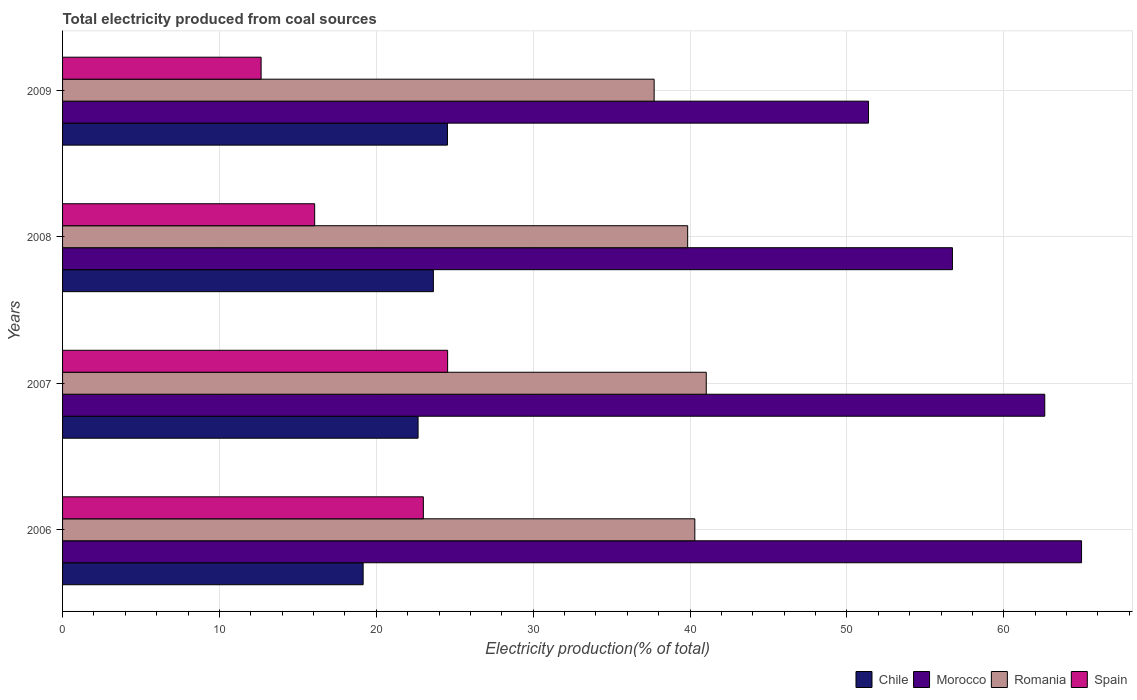How many different coloured bars are there?
Provide a short and direct response. 4. How many groups of bars are there?
Your answer should be compact. 4. Are the number of bars per tick equal to the number of legend labels?
Keep it short and to the point. Yes. Are the number of bars on each tick of the Y-axis equal?
Offer a terse response. Yes. How many bars are there on the 2nd tick from the top?
Your response must be concise. 4. How many bars are there on the 3rd tick from the bottom?
Offer a very short reply. 4. In how many cases, is the number of bars for a given year not equal to the number of legend labels?
Offer a terse response. 0. What is the total electricity produced in Romania in 2008?
Offer a very short reply. 39.85. Across all years, what is the maximum total electricity produced in Spain?
Ensure brevity in your answer.  24.54. Across all years, what is the minimum total electricity produced in Chile?
Provide a succinct answer. 19.16. In which year was the total electricity produced in Morocco maximum?
Offer a very short reply. 2006. In which year was the total electricity produced in Spain minimum?
Ensure brevity in your answer.  2009. What is the total total electricity produced in Romania in the graph?
Provide a short and direct response. 158.89. What is the difference between the total electricity produced in Chile in 2007 and that in 2008?
Provide a succinct answer. -0.98. What is the difference between the total electricity produced in Morocco in 2008 and the total electricity produced in Romania in 2007?
Offer a very short reply. 15.69. What is the average total electricity produced in Romania per year?
Offer a very short reply. 39.72. In the year 2006, what is the difference between the total electricity produced in Chile and total electricity produced in Spain?
Ensure brevity in your answer.  -3.84. In how many years, is the total electricity produced in Spain greater than 52 %?
Keep it short and to the point. 0. What is the ratio of the total electricity produced in Chile in 2008 to that in 2009?
Your response must be concise. 0.96. Is the total electricity produced in Romania in 2007 less than that in 2009?
Give a very brief answer. No. What is the difference between the highest and the second highest total electricity produced in Morocco?
Offer a terse response. 2.34. What is the difference between the highest and the lowest total electricity produced in Morocco?
Keep it short and to the point. 13.58. In how many years, is the total electricity produced in Chile greater than the average total electricity produced in Chile taken over all years?
Make the answer very short. 3. What does the 1st bar from the top in 2008 represents?
Your response must be concise. Spain. What does the 2nd bar from the bottom in 2006 represents?
Your answer should be compact. Morocco. Are all the bars in the graph horizontal?
Offer a very short reply. Yes. How many years are there in the graph?
Your response must be concise. 4. What is the difference between two consecutive major ticks on the X-axis?
Offer a terse response. 10. Are the values on the major ticks of X-axis written in scientific E-notation?
Provide a short and direct response. No. Does the graph contain any zero values?
Provide a short and direct response. No. Where does the legend appear in the graph?
Provide a succinct answer. Bottom right. How are the legend labels stacked?
Your answer should be very brief. Horizontal. What is the title of the graph?
Offer a very short reply. Total electricity produced from coal sources. What is the label or title of the X-axis?
Make the answer very short. Electricity production(% of total). What is the Electricity production(% of total) of Chile in 2006?
Your answer should be compact. 19.16. What is the Electricity production(% of total) of Morocco in 2006?
Offer a terse response. 64.95. What is the Electricity production(% of total) in Romania in 2006?
Keep it short and to the point. 40.3. What is the Electricity production(% of total) of Spain in 2006?
Offer a terse response. 23. What is the Electricity production(% of total) of Chile in 2007?
Your answer should be compact. 22.66. What is the Electricity production(% of total) in Morocco in 2007?
Provide a short and direct response. 62.61. What is the Electricity production(% of total) in Romania in 2007?
Your answer should be compact. 41.03. What is the Electricity production(% of total) of Spain in 2007?
Keep it short and to the point. 24.54. What is the Electricity production(% of total) in Chile in 2008?
Offer a very short reply. 23.64. What is the Electricity production(% of total) of Morocco in 2008?
Your answer should be very brief. 56.72. What is the Electricity production(% of total) in Romania in 2008?
Offer a very short reply. 39.85. What is the Electricity production(% of total) of Spain in 2008?
Offer a terse response. 16.07. What is the Electricity production(% of total) of Chile in 2009?
Provide a short and direct response. 24.53. What is the Electricity production(% of total) of Morocco in 2009?
Give a very brief answer. 51.37. What is the Electricity production(% of total) in Romania in 2009?
Offer a terse response. 37.71. What is the Electricity production(% of total) of Spain in 2009?
Offer a terse response. 12.66. Across all years, what is the maximum Electricity production(% of total) of Chile?
Give a very brief answer. 24.53. Across all years, what is the maximum Electricity production(% of total) in Morocco?
Your answer should be compact. 64.95. Across all years, what is the maximum Electricity production(% of total) in Romania?
Keep it short and to the point. 41.03. Across all years, what is the maximum Electricity production(% of total) of Spain?
Give a very brief answer. 24.54. Across all years, what is the minimum Electricity production(% of total) in Chile?
Your answer should be very brief. 19.16. Across all years, what is the minimum Electricity production(% of total) of Morocco?
Your response must be concise. 51.37. Across all years, what is the minimum Electricity production(% of total) of Romania?
Provide a succinct answer. 37.71. Across all years, what is the minimum Electricity production(% of total) of Spain?
Provide a short and direct response. 12.66. What is the total Electricity production(% of total) in Chile in the graph?
Keep it short and to the point. 89.99. What is the total Electricity production(% of total) of Morocco in the graph?
Ensure brevity in your answer.  235.65. What is the total Electricity production(% of total) in Romania in the graph?
Offer a very short reply. 158.89. What is the total Electricity production(% of total) in Spain in the graph?
Give a very brief answer. 76.27. What is the difference between the Electricity production(% of total) in Chile in 2006 and that in 2007?
Provide a succinct answer. -3.5. What is the difference between the Electricity production(% of total) of Morocco in 2006 and that in 2007?
Offer a very short reply. 2.34. What is the difference between the Electricity production(% of total) of Romania in 2006 and that in 2007?
Your answer should be compact. -0.73. What is the difference between the Electricity production(% of total) in Spain in 2006 and that in 2007?
Offer a very short reply. -1.55. What is the difference between the Electricity production(% of total) of Chile in 2006 and that in 2008?
Make the answer very short. -4.48. What is the difference between the Electricity production(% of total) in Morocco in 2006 and that in 2008?
Your response must be concise. 8.23. What is the difference between the Electricity production(% of total) in Romania in 2006 and that in 2008?
Make the answer very short. 0.46. What is the difference between the Electricity production(% of total) of Spain in 2006 and that in 2008?
Ensure brevity in your answer.  6.93. What is the difference between the Electricity production(% of total) in Chile in 2006 and that in 2009?
Provide a succinct answer. -5.37. What is the difference between the Electricity production(% of total) of Morocco in 2006 and that in 2009?
Your answer should be compact. 13.58. What is the difference between the Electricity production(% of total) of Romania in 2006 and that in 2009?
Your response must be concise. 2.59. What is the difference between the Electricity production(% of total) in Spain in 2006 and that in 2009?
Provide a succinct answer. 10.34. What is the difference between the Electricity production(% of total) of Chile in 2007 and that in 2008?
Provide a succinct answer. -0.98. What is the difference between the Electricity production(% of total) in Morocco in 2007 and that in 2008?
Your response must be concise. 5.89. What is the difference between the Electricity production(% of total) in Romania in 2007 and that in 2008?
Ensure brevity in your answer.  1.19. What is the difference between the Electricity production(% of total) of Spain in 2007 and that in 2008?
Offer a very short reply. 8.47. What is the difference between the Electricity production(% of total) in Chile in 2007 and that in 2009?
Ensure brevity in your answer.  -1.87. What is the difference between the Electricity production(% of total) in Morocco in 2007 and that in 2009?
Offer a very short reply. 11.23. What is the difference between the Electricity production(% of total) of Romania in 2007 and that in 2009?
Your response must be concise. 3.32. What is the difference between the Electricity production(% of total) of Spain in 2007 and that in 2009?
Provide a short and direct response. 11.89. What is the difference between the Electricity production(% of total) in Chile in 2008 and that in 2009?
Offer a terse response. -0.9. What is the difference between the Electricity production(% of total) of Morocco in 2008 and that in 2009?
Provide a succinct answer. 5.35. What is the difference between the Electricity production(% of total) in Romania in 2008 and that in 2009?
Offer a terse response. 2.14. What is the difference between the Electricity production(% of total) of Spain in 2008 and that in 2009?
Your answer should be compact. 3.41. What is the difference between the Electricity production(% of total) of Chile in 2006 and the Electricity production(% of total) of Morocco in 2007?
Your answer should be compact. -43.45. What is the difference between the Electricity production(% of total) in Chile in 2006 and the Electricity production(% of total) in Romania in 2007?
Offer a terse response. -21.87. What is the difference between the Electricity production(% of total) of Chile in 2006 and the Electricity production(% of total) of Spain in 2007?
Give a very brief answer. -5.39. What is the difference between the Electricity production(% of total) in Morocco in 2006 and the Electricity production(% of total) in Romania in 2007?
Make the answer very short. 23.92. What is the difference between the Electricity production(% of total) in Morocco in 2006 and the Electricity production(% of total) in Spain in 2007?
Offer a terse response. 40.41. What is the difference between the Electricity production(% of total) of Romania in 2006 and the Electricity production(% of total) of Spain in 2007?
Offer a very short reply. 15.76. What is the difference between the Electricity production(% of total) in Chile in 2006 and the Electricity production(% of total) in Morocco in 2008?
Provide a succinct answer. -37.56. What is the difference between the Electricity production(% of total) of Chile in 2006 and the Electricity production(% of total) of Romania in 2008?
Your answer should be compact. -20.69. What is the difference between the Electricity production(% of total) of Chile in 2006 and the Electricity production(% of total) of Spain in 2008?
Ensure brevity in your answer.  3.09. What is the difference between the Electricity production(% of total) of Morocco in 2006 and the Electricity production(% of total) of Romania in 2008?
Offer a very short reply. 25.11. What is the difference between the Electricity production(% of total) in Morocco in 2006 and the Electricity production(% of total) in Spain in 2008?
Ensure brevity in your answer.  48.88. What is the difference between the Electricity production(% of total) of Romania in 2006 and the Electricity production(% of total) of Spain in 2008?
Provide a short and direct response. 24.23. What is the difference between the Electricity production(% of total) in Chile in 2006 and the Electricity production(% of total) in Morocco in 2009?
Your response must be concise. -32.21. What is the difference between the Electricity production(% of total) in Chile in 2006 and the Electricity production(% of total) in Romania in 2009?
Your response must be concise. -18.55. What is the difference between the Electricity production(% of total) of Chile in 2006 and the Electricity production(% of total) of Spain in 2009?
Give a very brief answer. 6.5. What is the difference between the Electricity production(% of total) of Morocco in 2006 and the Electricity production(% of total) of Romania in 2009?
Ensure brevity in your answer.  27.24. What is the difference between the Electricity production(% of total) of Morocco in 2006 and the Electricity production(% of total) of Spain in 2009?
Give a very brief answer. 52.3. What is the difference between the Electricity production(% of total) in Romania in 2006 and the Electricity production(% of total) in Spain in 2009?
Provide a short and direct response. 27.65. What is the difference between the Electricity production(% of total) of Chile in 2007 and the Electricity production(% of total) of Morocco in 2008?
Provide a succinct answer. -34.06. What is the difference between the Electricity production(% of total) of Chile in 2007 and the Electricity production(% of total) of Romania in 2008?
Your answer should be very brief. -17.18. What is the difference between the Electricity production(% of total) in Chile in 2007 and the Electricity production(% of total) in Spain in 2008?
Provide a succinct answer. 6.59. What is the difference between the Electricity production(% of total) in Morocco in 2007 and the Electricity production(% of total) in Romania in 2008?
Make the answer very short. 22.76. What is the difference between the Electricity production(% of total) of Morocco in 2007 and the Electricity production(% of total) of Spain in 2008?
Provide a short and direct response. 46.54. What is the difference between the Electricity production(% of total) in Romania in 2007 and the Electricity production(% of total) in Spain in 2008?
Your answer should be very brief. 24.96. What is the difference between the Electricity production(% of total) of Chile in 2007 and the Electricity production(% of total) of Morocco in 2009?
Provide a short and direct response. -28.71. What is the difference between the Electricity production(% of total) in Chile in 2007 and the Electricity production(% of total) in Romania in 2009?
Give a very brief answer. -15.05. What is the difference between the Electricity production(% of total) in Chile in 2007 and the Electricity production(% of total) in Spain in 2009?
Keep it short and to the point. 10.01. What is the difference between the Electricity production(% of total) in Morocco in 2007 and the Electricity production(% of total) in Romania in 2009?
Keep it short and to the point. 24.9. What is the difference between the Electricity production(% of total) in Morocco in 2007 and the Electricity production(% of total) in Spain in 2009?
Make the answer very short. 49.95. What is the difference between the Electricity production(% of total) of Romania in 2007 and the Electricity production(% of total) of Spain in 2009?
Provide a succinct answer. 28.38. What is the difference between the Electricity production(% of total) in Chile in 2008 and the Electricity production(% of total) in Morocco in 2009?
Offer a very short reply. -27.74. What is the difference between the Electricity production(% of total) of Chile in 2008 and the Electricity production(% of total) of Romania in 2009?
Your answer should be very brief. -14.07. What is the difference between the Electricity production(% of total) of Chile in 2008 and the Electricity production(% of total) of Spain in 2009?
Your response must be concise. 10.98. What is the difference between the Electricity production(% of total) of Morocco in 2008 and the Electricity production(% of total) of Romania in 2009?
Keep it short and to the point. 19.01. What is the difference between the Electricity production(% of total) in Morocco in 2008 and the Electricity production(% of total) in Spain in 2009?
Your answer should be compact. 44.07. What is the difference between the Electricity production(% of total) of Romania in 2008 and the Electricity production(% of total) of Spain in 2009?
Give a very brief answer. 27.19. What is the average Electricity production(% of total) of Chile per year?
Your answer should be compact. 22.5. What is the average Electricity production(% of total) of Morocco per year?
Keep it short and to the point. 58.91. What is the average Electricity production(% of total) of Romania per year?
Offer a terse response. 39.72. What is the average Electricity production(% of total) in Spain per year?
Make the answer very short. 19.07. In the year 2006, what is the difference between the Electricity production(% of total) in Chile and Electricity production(% of total) in Morocco?
Ensure brevity in your answer.  -45.79. In the year 2006, what is the difference between the Electricity production(% of total) in Chile and Electricity production(% of total) in Romania?
Your answer should be very brief. -21.14. In the year 2006, what is the difference between the Electricity production(% of total) in Chile and Electricity production(% of total) in Spain?
Provide a short and direct response. -3.84. In the year 2006, what is the difference between the Electricity production(% of total) of Morocco and Electricity production(% of total) of Romania?
Make the answer very short. 24.65. In the year 2006, what is the difference between the Electricity production(% of total) of Morocco and Electricity production(% of total) of Spain?
Provide a succinct answer. 41.95. In the year 2006, what is the difference between the Electricity production(% of total) in Romania and Electricity production(% of total) in Spain?
Provide a succinct answer. 17.3. In the year 2007, what is the difference between the Electricity production(% of total) of Chile and Electricity production(% of total) of Morocco?
Ensure brevity in your answer.  -39.95. In the year 2007, what is the difference between the Electricity production(% of total) of Chile and Electricity production(% of total) of Romania?
Give a very brief answer. -18.37. In the year 2007, what is the difference between the Electricity production(% of total) in Chile and Electricity production(% of total) in Spain?
Give a very brief answer. -1.88. In the year 2007, what is the difference between the Electricity production(% of total) in Morocco and Electricity production(% of total) in Romania?
Keep it short and to the point. 21.58. In the year 2007, what is the difference between the Electricity production(% of total) in Morocco and Electricity production(% of total) in Spain?
Your answer should be compact. 38.06. In the year 2007, what is the difference between the Electricity production(% of total) in Romania and Electricity production(% of total) in Spain?
Keep it short and to the point. 16.49. In the year 2008, what is the difference between the Electricity production(% of total) in Chile and Electricity production(% of total) in Morocco?
Your answer should be very brief. -33.09. In the year 2008, what is the difference between the Electricity production(% of total) in Chile and Electricity production(% of total) in Romania?
Offer a terse response. -16.21. In the year 2008, what is the difference between the Electricity production(% of total) in Chile and Electricity production(% of total) in Spain?
Offer a terse response. 7.57. In the year 2008, what is the difference between the Electricity production(% of total) of Morocco and Electricity production(% of total) of Romania?
Offer a very short reply. 16.88. In the year 2008, what is the difference between the Electricity production(% of total) of Morocco and Electricity production(% of total) of Spain?
Keep it short and to the point. 40.65. In the year 2008, what is the difference between the Electricity production(% of total) in Romania and Electricity production(% of total) in Spain?
Your response must be concise. 23.78. In the year 2009, what is the difference between the Electricity production(% of total) in Chile and Electricity production(% of total) in Morocco?
Give a very brief answer. -26.84. In the year 2009, what is the difference between the Electricity production(% of total) of Chile and Electricity production(% of total) of Romania?
Give a very brief answer. -13.17. In the year 2009, what is the difference between the Electricity production(% of total) of Chile and Electricity production(% of total) of Spain?
Your answer should be very brief. 11.88. In the year 2009, what is the difference between the Electricity production(% of total) in Morocco and Electricity production(% of total) in Romania?
Provide a short and direct response. 13.67. In the year 2009, what is the difference between the Electricity production(% of total) in Morocco and Electricity production(% of total) in Spain?
Provide a short and direct response. 38.72. In the year 2009, what is the difference between the Electricity production(% of total) of Romania and Electricity production(% of total) of Spain?
Your response must be concise. 25.05. What is the ratio of the Electricity production(% of total) of Chile in 2006 to that in 2007?
Ensure brevity in your answer.  0.85. What is the ratio of the Electricity production(% of total) of Morocco in 2006 to that in 2007?
Your answer should be compact. 1.04. What is the ratio of the Electricity production(% of total) in Romania in 2006 to that in 2007?
Provide a succinct answer. 0.98. What is the ratio of the Electricity production(% of total) of Spain in 2006 to that in 2007?
Provide a succinct answer. 0.94. What is the ratio of the Electricity production(% of total) of Chile in 2006 to that in 2008?
Your answer should be very brief. 0.81. What is the ratio of the Electricity production(% of total) of Morocco in 2006 to that in 2008?
Offer a very short reply. 1.15. What is the ratio of the Electricity production(% of total) in Romania in 2006 to that in 2008?
Your answer should be compact. 1.01. What is the ratio of the Electricity production(% of total) in Spain in 2006 to that in 2008?
Provide a short and direct response. 1.43. What is the ratio of the Electricity production(% of total) of Chile in 2006 to that in 2009?
Offer a terse response. 0.78. What is the ratio of the Electricity production(% of total) in Morocco in 2006 to that in 2009?
Your answer should be compact. 1.26. What is the ratio of the Electricity production(% of total) of Romania in 2006 to that in 2009?
Provide a succinct answer. 1.07. What is the ratio of the Electricity production(% of total) of Spain in 2006 to that in 2009?
Your response must be concise. 1.82. What is the ratio of the Electricity production(% of total) of Chile in 2007 to that in 2008?
Make the answer very short. 0.96. What is the ratio of the Electricity production(% of total) of Morocco in 2007 to that in 2008?
Give a very brief answer. 1.1. What is the ratio of the Electricity production(% of total) in Romania in 2007 to that in 2008?
Offer a very short reply. 1.03. What is the ratio of the Electricity production(% of total) in Spain in 2007 to that in 2008?
Your answer should be compact. 1.53. What is the ratio of the Electricity production(% of total) in Chile in 2007 to that in 2009?
Offer a terse response. 0.92. What is the ratio of the Electricity production(% of total) of Morocco in 2007 to that in 2009?
Your response must be concise. 1.22. What is the ratio of the Electricity production(% of total) of Romania in 2007 to that in 2009?
Give a very brief answer. 1.09. What is the ratio of the Electricity production(% of total) of Spain in 2007 to that in 2009?
Your response must be concise. 1.94. What is the ratio of the Electricity production(% of total) in Chile in 2008 to that in 2009?
Your answer should be compact. 0.96. What is the ratio of the Electricity production(% of total) in Morocco in 2008 to that in 2009?
Provide a short and direct response. 1.1. What is the ratio of the Electricity production(% of total) of Romania in 2008 to that in 2009?
Offer a very short reply. 1.06. What is the ratio of the Electricity production(% of total) in Spain in 2008 to that in 2009?
Your answer should be compact. 1.27. What is the difference between the highest and the second highest Electricity production(% of total) in Chile?
Your answer should be very brief. 0.9. What is the difference between the highest and the second highest Electricity production(% of total) of Morocco?
Provide a short and direct response. 2.34. What is the difference between the highest and the second highest Electricity production(% of total) in Romania?
Your answer should be compact. 0.73. What is the difference between the highest and the second highest Electricity production(% of total) in Spain?
Give a very brief answer. 1.55. What is the difference between the highest and the lowest Electricity production(% of total) in Chile?
Offer a terse response. 5.37. What is the difference between the highest and the lowest Electricity production(% of total) in Morocco?
Your answer should be very brief. 13.58. What is the difference between the highest and the lowest Electricity production(% of total) in Romania?
Provide a succinct answer. 3.32. What is the difference between the highest and the lowest Electricity production(% of total) in Spain?
Offer a very short reply. 11.89. 